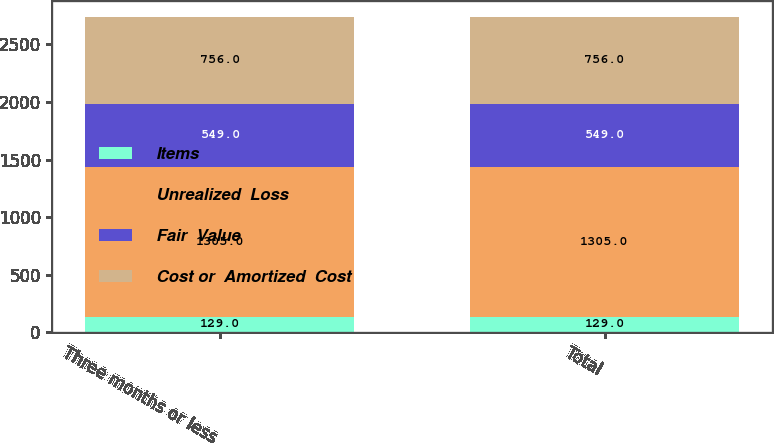<chart> <loc_0><loc_0><loc_500><loc_500><stacked_bar_chart><ecel><fcel>Three months or less<fcel>Total<nl><fcel>Items<fcel>129<fcel>129<nl><fcel>Unrealized  Loss<fcel>1305<fcel>1305<nl><fcel>Fair  Value<fcel>549<fcel>549<nl><fcel>Cost or  Amortized  Cost<fcel>756<fcel>756<nl></chart> 